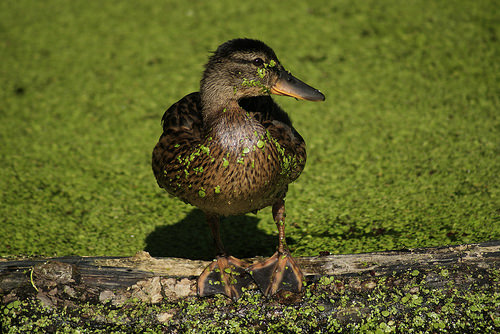<image>
Can you confirm if the bird is on the tree? Yes. Looking at the image, I can see the bird is positioned on top of the tree, with the tree providing support. 